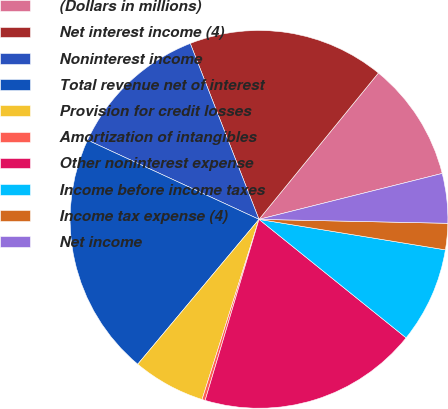Convert chart to OTSL. <chart><loc_0><loc_0><loc_500><loc_500><pie_chart><fcel>(Dollars in millions)<fcel>Net interest income (4)<fcel>Noninterest income<fcel>Total revenue net of interest<fcel>Provision for credit losses<fcel>Amortization of intangibles<fcel>Other noninterest expense<fcel>Income before income taxes<fcel>Income tax expense (4)<fcel>Net income<nl><fcel>10.2%<fcel>16.82%<fcel>12.18%<fcel>20.8%<fcel>6.22%<fcel>0.27%<fcel>18.81%<fcel>8.21%<fcel>2.25%<fcel>4.24%<nl></chart> 